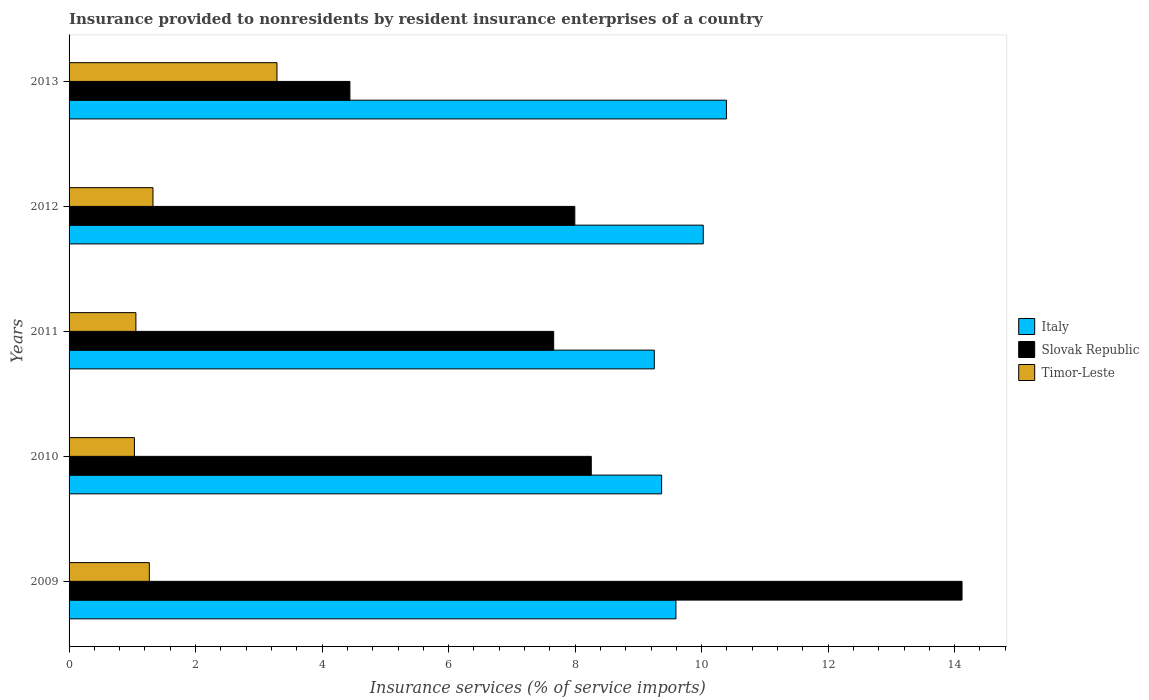How many different coloured bars are there?
Ensure brevity in your answer.  3. How many groups of bars are there?
Make the answer very short. 5. Are the number of bars per tick equal to the number of legend labels?
Your response must be concise. Yes. Are the number of bars on each tick of the Y-axis equal?
Offer a terse response. Yes. How many bars are there on the 5th tick from the top?
Offer a very short reply. 3. How many bars are there on the 2nd tick from the bottom?
Give a very brief answer. 3. What is the label of the 1st group of bars from the top?
Ensure brevity in your answer.  2013. What is the insurance provided to nonresidents in Italy in 2009?
Your answer should be compact. 9.59. Across all years, what is the maximum insurance provided to nonresidents in Italy?
Your answer should be very brief. 10.39. Across all years, what is the minimum insurance provided to nonresidents in Timor-Leste?
Keep it short and to the point. 1.03. In which year was the insurance provided to nonresidents in Italy maximum?
Make the answer very short. 2013. What is the total insurance provided to nonresidents in Slovak Republic in the graph?
Give a very brief answer. 42.47. What is the difference between the insurance provided to nonresidents in Timor-Leste in 2012 and that in 2013?
Make the answer very short. -1.96. What is the difference between the insurance provided to nonresidents in Timor-Leste in 2013 and the insurance provided to nonresidents in Slovak Republic in 2012?
Keep it short and to the point. -4.71. What is the average insurance provided to nonresidents in Slovak Republic per year?
Offer a terse response. 8.49. In the year 2011, what is the difference between the insurance provided to nonresidents in Timor-Leste and insurance provided to nonresidents in Slovak Republic?
Ensure brevity in your answer.  -6.6. In how many years, is the insurance provided to nonresidents in Slovak Republic greater than 12 %?
Keep it short and to the point. 1. What is the ratio of the insurance provided to nonresidents in Slovak Republic in 2011 to that in 2012?
Keep it short and to the point. 0.96. What is the difference between the highest and the second highest insurance provided to nonresidents in Timor-Leste?
Offer a very short reply. 1.96. What is the difference between the highest and the lowest insurance provided to nonresidents in Italy?
Your response must be concise. 1.14. In how many years, is the insurance provided to nonresidents in Italy greater than the average insurance provided to nonresidents in Italy taken over all years?
Provide a short and direct response. 2. Is the sum of the insurance provided to nonresidents in Slovak Republic in 2010 and 2012 greater than the maximum insurance provided to nonresidents in Italy across all years?
Your answer should be very brief. Yes. What does the 1st bar from the top in 2012 represents?
Offer a very short reply. Timor-Leste. What does the 3rd bar from the bottom in 2009 represents?
Your answer should be compact. Timor-Leste. Is it the case that in every year, the sum of the insurance provided to nonresidents in Slovak Republic and insurance provided to nonresidents in Italy is greater than the insurance provided to nonresidents in Timor-Leste?
Offer a very short reply. Yes. How many bars are there?
Keep it short and to the point. 15. Are all the bars in the graph horizontal?
Keep it short and to the point. Yes. How many years are there in the graph?
Your answer should be compact. 5. Are the values on the major ticks of X-axis written in scientific E-notation?
Make the answer very short. No. How many legend labels are there?
Offer a terse response. 3. How are the legend labels stacked?
Offer a terse response. Vertical. What is the title of the graph?
Offer a very short reply. Insurance provided to nonresidents by resident insurance enterprises of a country. Does "Guyana" appear as one of the legend labels in the graph?
Provide a short and direct response. No. What is the label or title of the X-axis?
Offer a terse response. Insurance services (% of service imports). What is the label or title of the Y-axis?
Keep it short and to the point. Years. What is the Insurance services (% of service imports) of Italy in 2009?
Provide a succinct answer. 9.59. What is the Insurance services (% of service imports) of Slovak Republic in 2009?
Your answer should be compact. 14.12. What is the Insurance services (% of service imports) in Timor-Leste in 2009?
Ensure brevity in your answer.  1.27. What is the Insurance services (% of service imports) of Italy in 2010?
Provide a succinct answer. 9.37. What is the Insurance services (% of service imports) of Slovak Republic in 2010?
Your response must be concise. 8.26. What is the Insurance services (% of service imports) in Timor-Leste in 2010?
Offer a very short reply. 1.03. What is the Insurance services (% of service imports) in Italy in 2011?
Keep it short and to the point. 9.25. What is the Insurance services (% of service imports) of Slovak Republic in 2011?
Provide a short and direct response. 7.66. What is the Insurance services (% of service imports) of Timor-Leste in 2011?
Give a very brief answer. 1.06. What is the Insurance services (% of service imports) of Italy in 2012?
Make the answer very short. 10.03. What is the Insurance services (% of service imports) of Slovak Republic in 2012?
Your response must be concise. 8. What is the Insurance services (% of service imports) of Timor-Leste in 2012?
Your answer should be very brief. 1.33. What is the Insurance services (% of service imports) in Italy in 2013?
Provide a succinct answer. 10.39. What is the Insurance services (% of service imports) in Slovak Republic in 2013?
Provide a succinct answer. 4.44. What is the Insurance services (% of service imports) of Timor-Leste in 2013?
Offer a terse response. 3.29. Across all years, what is the maximum Insurance services (% of service imports) in Italy?
Give a very brief answer. 10.39. Across all years, what is the maximum Insurance services (% of service imports) of Slovak Republic?
Keep it short and to the point. 14.12. Across all years, what is the maximum Insurance services (% of service imports) in Timor-Leste?
Offer a very short reply. 3.29. Across all years, what is the minimum Insurance services (% of service imports) of Italy?
Ensure brevity in your answer.  9.25. Across all years, what is the minimum Insurance services (% of service imports) in Slovak Republic?
Offer a very short reply. 4.44. Across all years, what is the minimum Insurance services (% of service imports) in Timor-Leste?
Keep it short and to the point. 1.03. What is the total Insurance services (% of service imports) in Italy in the graph?
Provide a succinct answer. 48.63. What is the total Insurance services (% of service imports) of Slovak Republic in the graph?
Make the answer very short. 42.47. What is the total Insurance services (% of service imports) in Timor-Leste in the graph?
Offer a terse response. 7.97. What is the difference between the Insurance services (% of service imports) in Italy in 2009 and that in 2010?
Provide a short and direct response. 0.23. What is the difference between the Insurance services (% of service imports) in Slovak Republic in 2009 and that in 2010?
Make the answer very short. 5.86. What is the difference between the Insurance services (% of service imports) in Timor-Leste in 2009 and that in 2010?
Keep it short and to the point. 0.24. What is the difference between the Insurance services (% of service imports) of Italy in 2009 and that in 2011?
Offer a very short reply. 0.34. What is the difference between the Insurance services (% of service imports) in Slovak Republic in 2009 and that in 2011?
Offer a very short reply. 6.46. What is the difference between the Insurance services (% of service imports) of Timor-Leste in 2009 and that in 2011?
Your answer should be very brief. 0.21. What is the difference between the Insurance services (% of service imports) of Italy in 2009 and that in 2012?
Give a very brief answer. -0.43. What is the difference between the Insurance services (% of service imports) of Slovak Republic in 2009 and that in 2012?
Ensure brevity in your answer.  6.12. What is the difference between the Insurance services (% of service imports) of Timor-Leste in 2009 and that in 2012?
Offer a terse response. -0.06. What is the difference between the Insurance services (% of service imports) of Italy in 2009 and that in 2013?
Ensure brevity in your answer.  -0.8. What is the difference between the Insurance services (% of service imports) of Slovak Republic in 2009 and that in 2013?
Keep it short and to the point. 9.68. What is the difference between the Insurance services (% of service imports) in Timor-Leste in 2009 and that in 2013?
Offer a very short reply. -2.02. What is the difference between the Insurance services (% of service imports) in Italy in 2010 and that in 2011?
Ensure brevity in your answer.  0.12. What is the difference between the Insurance services (% of service imports) of Slovak Republic in 2010 and that in 2011?
Make the answer very short. 0.59. What is the difference between the Insurance services (% of service imports) in Timor-Leste in 2010 and that in 2011?
Your answer should be compact. -0.02. What is the difference between the Insurance services (% of service imports) in Italy in 2010 and that in 2012?
Ensure brevity in your answer.  -0.66. What is the difference between the Insurance services (% of service imports) in Slovak Republic in 2010 and that in 2012?
Offer a terse response. 0.26. What is the difference between the Insurance services (% of service imports) of Timor-Leste in 2010 and that in 2012?
Offer a terse response. -0.29. What is the difference between the Insurance services (% of service imports) in Italy in 2010 and that in 2013?
Your answer should be very brief. -1.02. What is the difference between the Insurance services (% of service imports) in Slovak Republic in 2010 and that in 2013?
Give a very brief answer. 3.82. What is the difference between the Insurance services (% of service imports) in Timor-Leste in 2010 and that in 2013?
Your answer should be compact. -2.25. What is the difference between the Insurance services (% of service imports) of Italy in 2011 and that in 2012?
Make the answer very short. -0.77. What is the difference between the Insurance services (% of service imports) of Slovak Republic in 2011 and that in 2012?
Your response must be concise. -0.33. What is the difference between the Insurance services (% of service imports) of Timor-Leste in 2011 and that in 2012?
Offer a very short reply. -0.27. What is the difference between the Insurance services (% of service imports) of Italy in 2011 and that in 2013?
Make the answer very short. -1.14. What is the difference between the Insurance services (% of service imports) of Slovak Republic in 2011 and that in 2013?
Your response must be concise. 3.22. What is the difference between the Insurance services (% of service imports) in Timor-Leste in 2011 and that in 2013?
Give a very brief answer. -2.23. What is the difference between the Insurance services (% of service imports) of Italy in 2012 and that in 2013?
Your answer should be very brief. -0.37. What is the difference between the Insurance services (% of service imports) of Slovak Republic in 2012 and that in 2013?
Give a very brief answer. 3.56. What is the difference between the Insurance services (% of service imports) of Timor-Leste in 2012 and that in 2013?
Ensure brevity in your answer.  -1.96. What is the difference between the Insurance services (% of service imports) of Italy in 2009 and the Insurance services (% of service imports) of Slovak Republic in 2010?
Your response must be concise. 1.34. What is the difference between the Insurance services (% of service imports) of Italy in 2009 and the Insurance services (% of service imports) of Timor-Leste in 2010?
Provide a short and direct response. 8.56. What is the difference between the Insurance services (% of service imports) of Slovak Republic in 2009 and the Insurance services (% of service imports) of Timor-Leste in 2010?
Provide a short and direct response. 13.08. What is the difference between the Insurance services (% of service imports) in Italy in 2009 and the Insurance services (% of service imports) in Slovak Republic in 2011?
Give a very brief answer. 1.93. What is the difference between the Insurance services (% of service imports) in Italy in 2009 and the Insurance services (% of service imports) in Timor-Leste in 2011?
Make the answer very short. 8.54. What is the difference between the Insurance services (% of service imports) in Slovak Republic in 2009 and the Insurance services (% of service imports) in Timor-Leste in 2011?
Ensure brevity in your answer.  13.06. What is the difference between the Insurance services (% of service imports) in Italy in 2009 and the Insurance services (% of service imports) in Slovak Republic in 2012?
Your answer should be very brief. 1.6. What is the difference between the Insurance services (% of service imports) of Italy in 2009 and the Insurance services (% of service imports) of Timor-Leste in 2012?
Offer a very short reply. 8.27. What is the difference between the Insurance services (% of service imports) of Slovak Republic in 2009 and the Insurance services (% of service imports) of Timor-Leste in 2012?
Give a very brief answer. 12.79. What is the difference between the Insurance services (% of service imports) in Italy in 2009 and the Insurance services (% of service imports) in Slovak Republic in 2013?
Offer a terse response. 5.15. What is the difference between the Insurance services (% of service imports) of Italy in 2009 and the Insurance services (% of service imports) of Timor-Leste in 2013?
Make the answer very short. 6.31. What is the difference between the Insurance services (% of service imports) in Slovak Republic in 2009 and the Insurance services (% of service imports) in Timor-Leste in 2013?
Offer a very short reply. 10.83. What is the difference between the Insurance services (% of service imports) in Italy in 2010 and the Insurance services (% of service imports) in Slovak Republic in 2011?
Your response must be concise. 1.71. What is the difference between the Insurance services (% of service imports) of Italy in 2010 and the Insurance services (% of service imports) of Timor-Leste in 2011?
Your answer should be very brief. 8.31. What is the difference between the Insurance services (% of service imports) of Slovak Republic in 2010 and the Insurance services (% of service imports) of Timor-Leste in 2011?
Give a very brief answer. 7.2. What is the difference between the Insurance services (% of service imports) of Italy in 2010 and the Insurance services (% of service imports) of Slovak Republic in 2012?
Make the answer very short. 1.37. What is the difference between the Insurance services (% of service imports) of Italy in 2010 and the Insurance services (% of service imports) of Timor-Leste in 2012?
Offer a very short reply. 8.04. What is the difference between the Insurance services (% of service imports) in Slovak Republic in 2010 and the Insurance services (% of service imports) in Timor-Leste in 2012?
Give a very brief answer. 6.93. What is the difference between the Insurance services (% of service imports) of Italy in 2010 and the Insurance services (% of service imports) of Slovak Republic in 2013?
Offer a terse response. 4.93. What is the difference between the Insurance services (% of service imports) in Italy in 2010 and the Insurance services (% of service imports) in Timor-Leste in 2013?
Offer a terse response. 6.08. What is the difference between the Insurance services (% of service imports) of Slovak Republic in 2010 and the Insurance services (% of service imports) of Timor-Leste in 2013?
Your answer should be compact. 4.97. What is the difference between the Insurance services (% of service imports) of Italy in 2011 and the Insurance services (% of service imports) of Slovak Republic in 2012?
Provide a succinct answer. 1.26. What is the difference between the Insurance services (% of service imports) in Italy in 2011 and the Insurance services (% of service imports) in Timor-Leste in 2012?
Provide a short and direct response. 7.93. What is the difference between the Insurance services (% of service imports) in Slovak Republic in 2011 and the Insurance services (% of service imports) in Timor-Leste in 2012?
Keep it short and to the point. 6.33. What is the difference between the Insurance services (% of service imports) of Italy in 2011 and the Insurance services (% of service imports) of Slovak Republic in 2013?
Offer a terse response. 4.81. What is the difference between the Insurance services (% of service imports) of Italy in 2011 and the Insurance services (% of service imports) of Timor-Leste in 2013?
Offer a very short reply. 5.96. What is the difference between the Insurance services (% of service imports) of Slovak Republic in 2011 and the Insurance services (% of service imports) of Timor-Leste in 2013?
Your answer should be compact. 4.37. What is the difference between the Insurance services (% of service imports) of Italy in 2012 and the Insurance services (% of service imports) of Slovak Republic in 2013?
Offer a very short reply. 5.59. What is the difference between the Insurance services (% of service imports) in Italy in 2012 and the Insurance services (% of service imports) in Timor-Leste in 2013?
Provide a succinct answer. 6.74. What is the difference between the Insurance services (% of service imports) in Slovak Republic in 2012 and the Insurance services (% of service imports) in Timor-Leste in 2013?
Provide a succinct answer. 4.71. What is the average Insurance services (% of service imports) of Italy per year?
Your answer should be compact. 9.73. What is the average Insurance services (% of service imports) of Slovak Republic per year?
Keep it short and to the point. 8.49. What is the average Insurance services (% of service imports) of Timor-Leste per year?
Ensure brevity in your answer.  1.59. In the year 2009, what is the difference between the Insurance services (% of service imports) in Italy and Insurance services (% of service imports) in Slovak Republic?
Your answer should be very brief. -4.52. In the year 2009, what is the difference between the Insurance services (% of service imports) in Italy and Insurance services (% of service imports) in Timor-Leste?
Offer a terse response. 8.32. In the year 2009, what is the difference between the Insurance services (% of service imports) in Slovak Republic and Insurance services (% of service imports) in Timor-Leste?
Provide a succinct answer. 12.85. In the year 2010, what is the difference between the Insurance services (% of service imports) in Italy and Insurance services (% of service imports) in Slovak Republic?
Your response must be concise. 1.11. In the year 2010, what is the difference between the Insurance services (% of service imports) of Italy and Insurance services (% of service imports) of Timor-Leste?
Offer a very short reply. 8.33. In the year 2010, what is the difference between the Insurance services (% of service imports) of Slovak Republic and Insurance services (% of service imports) of Timor-Leste?
Make the answer very short. 7.22. In the year 2011, what is the difference between the Insurance services (% of service imports) in Italy and Insurance services (% of service imports) in Slovak Republic?
Provide a succinct answer. 1.59. In the year 2011, what is the difference between the Insurance services (% of service imports) in Italy and Insurance services (% of service imports) in Timor-Leste?
Provide a succinct answer. 8.2. In the year 2011, what is the difference between the Insurance services (% of service imports) of Slovak Republic and Insurance services (% of service imports) of Timor-Leste?
Make the answer very short. 6.6. In the year 2012, what is the difference between the Insurance services (% of service imports) in Italy and Insurance services (% of service imports) in Slovak Republic?
Offer a terse response. 2.03. In the year 2012, what is the difference between the Insurance services (% of service imports) in Italy and Insurance services (% of service imports) in Timor-Leste?
Your response must be concise. 8.7. In the year 2012, what is the difference between the Insurance services (% of service imports) of Slovak Republic and Insurance services (% of service imports) of Timor-Leste?
Your response must be concise. 6.67. In the year 2013, what is the difference between the Insurance services (% of service imports) in Italy and Insurance services (% of service imports) in Slovak Republic?
Your answer should be very brief. 5.95. In the year 2013, what is the difference between the Insurance services (% of service imports) of Italy and Insurance services (% of service imports) of Timor-Leste?
Keep it short and to the point. 7.11. In the year 2013, what is the difference between the Insurance services (% of service imports) of Slovak Republic and Insurance services (% of service imports) of Timor-Leste?
Your answer should be compact. 1.15. What is the ratio of the Insurance services (% of service imports) of Italy in 2009 to that in 2010?
Make the answer very short. 1.02. What is the ratio of the Insurance services (% of service imports) in Slovak Republic in 2009 to that in 2010?
Offer a very short reply. 1.71. What is the ratio of the Insurance services (% of service imports) of Timor-Leste in 2009 to that in 2010?
Your response must be concise. 1.23. What is the ratio of the Insurance services (% of service imports) of Slovak Republic in 2009 to that in 2011?
Provide a succinct answer. 1.84. What is the ratio of the Insurance services (% of service imports) of Timor-Leste in 2009 to that in 2011?
Your answer should be compact. 1.2. What is the ratio of the Insurance services (% of service imports) in Italy in 2009 to that in 2012?
Provide a succinct answer. 0.96. What is the ratio of the Insurance services (% of service imports) of Slovak Republic in 2009 to that in 2012?
Make the answer very short. 1.77. What is the ratio of the Insurance services (% of service imports) of Timor-Leste in 2009 to that in 2012?
Provide a short and direct response. 0.96. What is the ratio of the Insurance services (% of service imports) of Italy in 2009 to that in 2013?
Your response must be concise. 0.92. What is the ratio of the Insurance services (% of service imports) in Slovak Republic in 2009 to that in 2013?
Make the answer very short. 3.18. What is the ratio of the Insurance services (% of service imports) in Timor-Leste in 2009 to that in 2013?
Your answer should be compact. 0.39. What is the ratio of the Insurance services (% of service imports) of Italy in 2010 to that in 2011?
Keep it short and to the point. 1.01. What is the ratio of the Insurance services (% of service imports) of Slovak Republic in 2010 to that in 2011?
Keep it short and to the point. 1.08. What is the ratio of the Insurance services (% of service imports) in Timor-Leste in 2010 to that in 2011?
Ensure brevity in your answer.  0.98. What is the ratio of the Insurance services (% of service imports) in Italy in 2010 to that in 2012?
Offer a terse response. 0.93. What is the ratio of the Insurance services (% of service imports) in Slovak Republic in 2010 to that in 2012?
Your answer should be compact. 1.03. What is the ratio of the Insurance services (% of service imports) of Timor-Leste in 2010 to that in 2012?
Ensure brevity in your answer.  0.78. What is the ratio of the Insurance services (% of service imports) of Italy in 2010 to that in 2013?
Offer a terse response. 0.9. What is the ratio of the Insurance services (% of service imports) of Slovak Republic in 2010 to that in 2013?
Your answer should be compact. 1.86. What is the ratio of the Insurance services (% of service imports) of Timor-Leste in 2010 to that in 2013?
Ensure brevity in your answer.  0.31. What is the ratio of the Insurance services (% of service imports) in Italy in 2011 to that in 2012?
Offer a terse response. 0.92. What is the ratio of the Insurance services (% of service imports) in Slovak Republic in 2011 to that in 2012?
Give a very brief answer. 0.96. What is the ratio of the Insurance services (% of service imports) of Timor-Leste in 2011 to that in 2012?
Offer a terse response. 0.8. What is the ratio of the Insurance services (% of service imports) of Italy in 2011 to that in 2013?
Make the answer very short. 0.89. What is the ratio of the Insurance services (% of service imports) in Slovak Republic in 2011 to that in 2013?
Your answer should be compact. 1.73. What is the ratio of the Insurance services (% of service imports) of Timor-Leste in 2011 to that in 2013?
Your response must be concise. 0.32. What is the ratio of the Insurance services (% of service imports) of Italy in 2012 to that in 2013?
Your answer should be compact. 0.96. What is the ratio of the Insurance services (% of service imports) in Slovak Republic in 2012 to that in 2013?
Provide a succinct answer. 1.8. What is the ratio of the Insurance services (% of service imports) in Timor-Leste in 2012 to that in 2013?
Keep it short and to the point. 0.4. What is the difference between the highest and the second highest Insurance services (% of service imports) of Italy?
Offer a very short reply. 0.37. What is the difference between the highest and the second highest Insurance services (% of service imports) of Slovak Republic?
Give a very brief answer. 5.86. What is the difference between the highest and the second highest Insurance services (% of service imports) in Timor-Leste?
Provide a succinct answer. 1.96. What is the difference between the highest and the lowest Insurance services (% of service imports) in Italy?
Your answer should be compact. 1.14. What is the difference between the highest and the lowest Insurance services (% of service imports) in Slovak Republic?
Provide a short and direct response. 9.68. What is the difference between the highest and the lowest Insurance services (% of service imports) of Timor-Leste?
Your answer should be compact. 2.25. 